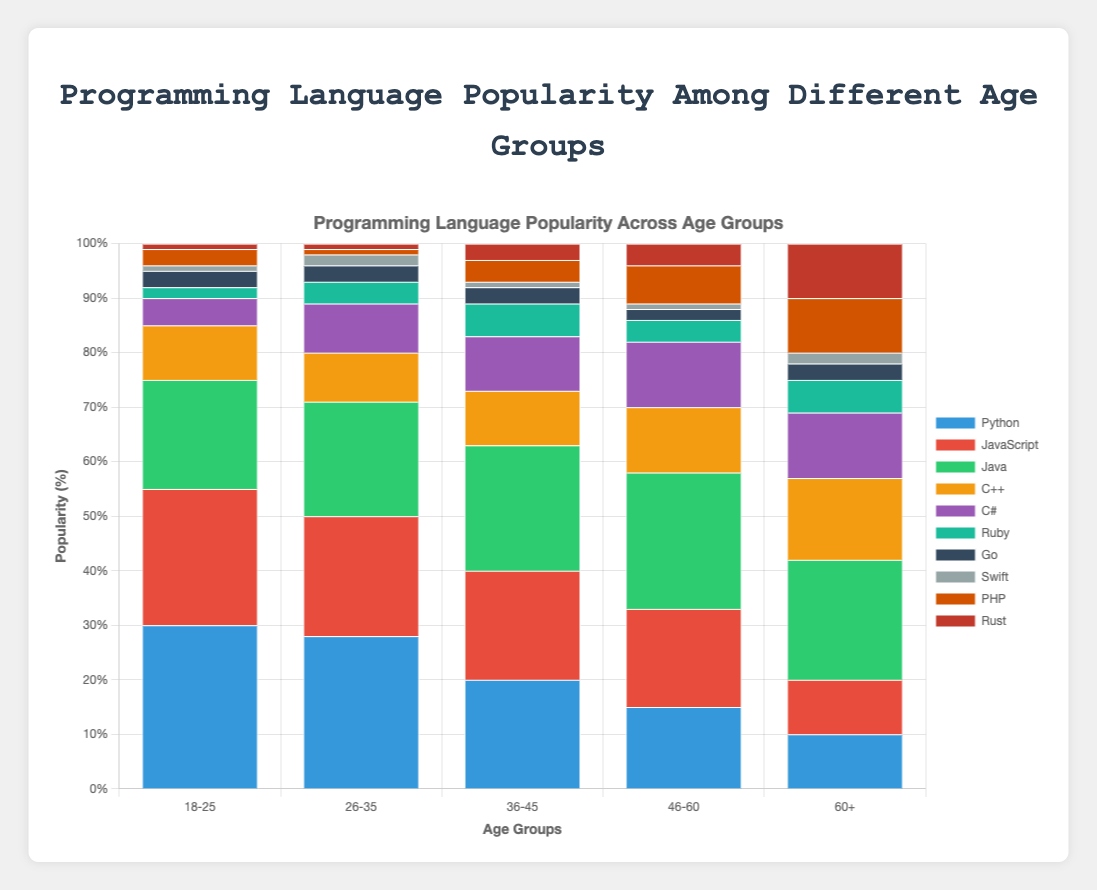What is the most popular programming language among the age group 18-25? By looking at the stacked bar chart for the age group 18-25, identify which language has the tallest segment. Python has the tallest segment, indicating its popularity among this age group.
Answer: Python Which age group shows the highest percentage for JavaScript? Compare the height of the JavaScript segments across all age groups. The age group with the tallest JavaScript segment is the group with the highest percentage. The age group 18-25 has the tallest JavaScript segment.
Answer: 18-25 In the age group 46-60, what is the combined popularity percentage of Python, JavaScript, and Java? For the age group 46-60, sum the segments' heights for Python (15%), JavaScript (18%), and Java (25%): 15 + 18 + 25 = 58%.
Answer: 58% Which programming language has a higher popularity in the age group 60+, C++ or PHP? In the age group 60+, compare the heights of the segments representing C++ and PHP. C++ has a 15% segment, while PHP has a 10% segment. Thus, C++ is more popular.
Answer: C++ Which age group has the lowest percentage of Swift users? Check the heights of the Swift segments across all age groups. The age group with the shortest Swift segment is the one with the lowest percentage. The age groups 18-25 and 46-60 both have the shortest segment for Swift at 1%.
Answer: 18-25 and 46-60 In the age group 36-45, how much more popular is Java compared to Python? For the age group 36-45, subtract the height of the Python segment (20%) from the height of the Java segment (23%): 23 - 20 = 3%.
Answer: 3% Between the age group 26-35 and the age group 36-45, which group uses Ruby more? Compare the heights of the Ruby segments between the age groups 26-35 and 36-45. The age group 36-45 has a Ruby segment of 6%, while the age group 26-35 has a segment of 4%. Thus, the age group 36-45 uses Ruby more.
Answer: 36-45 What is the total percentage of Go users across all age groups? Sum the heights of the Go segments for all age groups: 3% (18-25) + 3% (26-35) + 3% (36-45) + 2% (46-60) + 3% (60+): 3 + 3 + 3 + 2 + 3 = 14%.
Answer: 14% Which age group shows an equal popularity percentage for C# and C++? Look for an age group where the heights of the C# and C++ segments are the same. In the age groups 36-45 and 60+, the segments for C# and C++ are equal, both being 10% and 12% respectively.
Answer: 36-45 and 60+ Which language has the least variance in popularity across all age groups? Compare the range (difference between maximum and minimum values) of the segments of each language across all age groups. Go has the least variance, fluctuating between 2-3%.
Answer: Go 